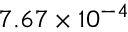<formula> <loc_0><loc_0><loc_500><loc_500>7 . 6 7 \times 1 0 ^ { - 4 }</formula> 